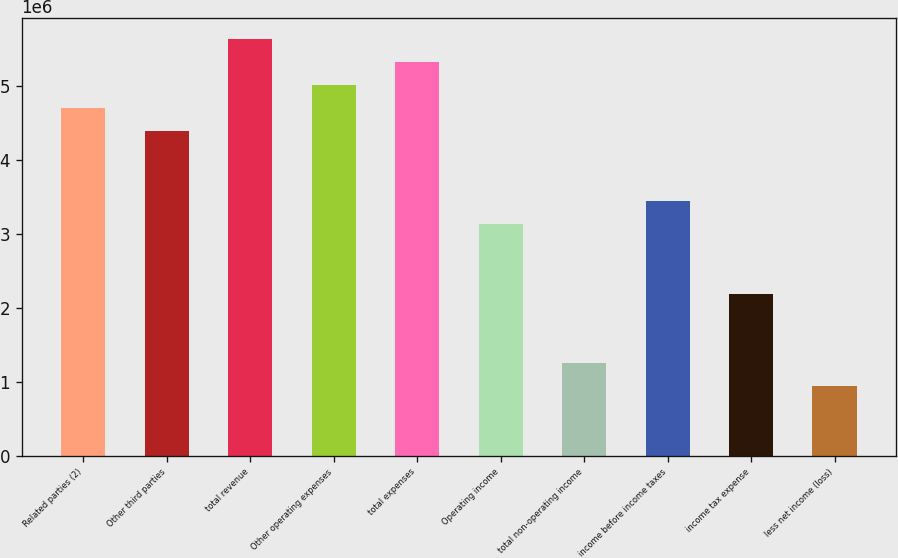<chart> <loc_0><loc_0><loc_500><loc_500><bar_chart><fcel>Related parties (2)<fcel>Other third parties<fcel>total revenue<fcel>Other operating expenses<fcel>total expenses<fcel>Operating income<fcel>total non-operating income<fcel>income before income taxes<fcel>income tax expense<fcel>less net income (loss)<nl><fcel>4.69667e+06<fcel>4.38356e+06<fcel>5.63601e+06<fcel>5.00978e+06<fcel>5.32289e+06<fcel>3.13112e+06<fcel>1.25245e+06<fcel>3.44423e+06<fcel>2.19178e+06<fcel>939338<nl></chart> 